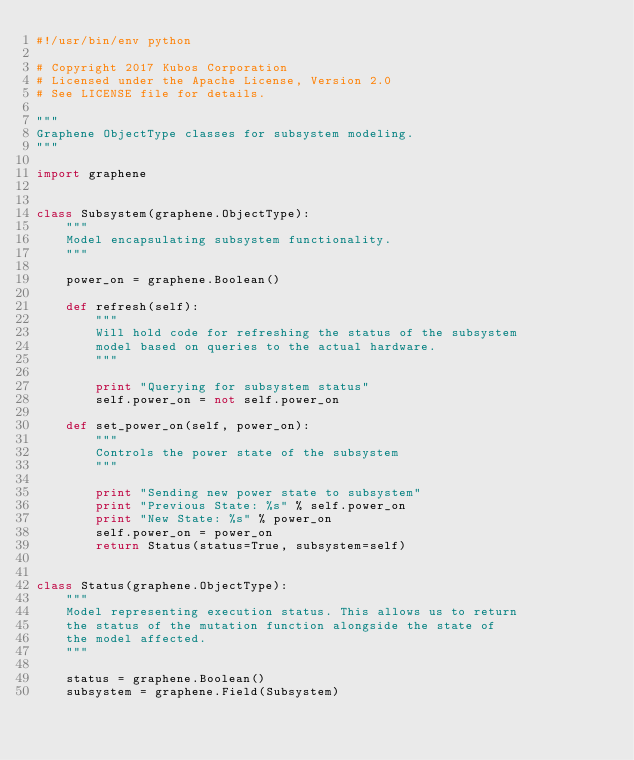<code> <loc_0><loc_0><loc_500><loc_500><_Python_>#!/usr/bin/env python

# Copyright 2017 Kubos Corporation
# Licensed under the Apache License, Version 2.0
# See LICENSE file for details.

"""
Graphene ObjectType classes for subsystem modeling.
"""

import graphene


class Subsystem(graphene.ObjectType):
    """
    Model encapsulating subsystem functionality.
    """

    power_on = graphene.Boolean()

    def refresh(self):
        """
        Will hold code for refreshing the status of the subsystem
        model based on queries to the actual hardware.
        """

        print "Querying for subsystem status"
        self.power_on = not self.power_on

    def set_power_on(self, power_on):
        """
        Controls the power state of the subsystem
        """

        print "Sending new power state to subsystem"
        print "Previous State: %s" % self.power_on
        print "New State: %s" % power_on
        self.power_on = power_on
        return Status(status=True, subsystem=self)


class Status(graphene.ObjectType):
    """
    Model representing execution status. This allows us to return
    the status of the mutation function alongside the state of
    the model affected.
    """

    status = graphene.Boolean()
    subsystem = graphene.Field(Subsystem)
</code> 